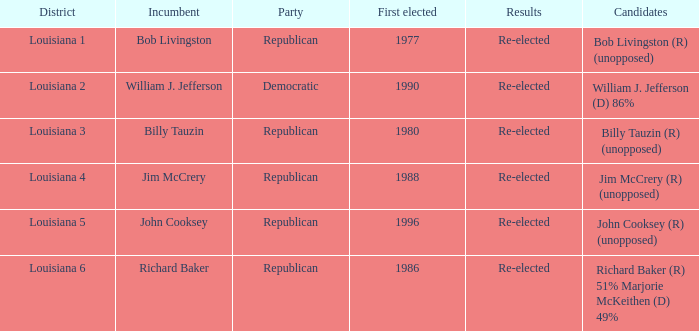How many applicants were elected first in 1980? 1.0. 